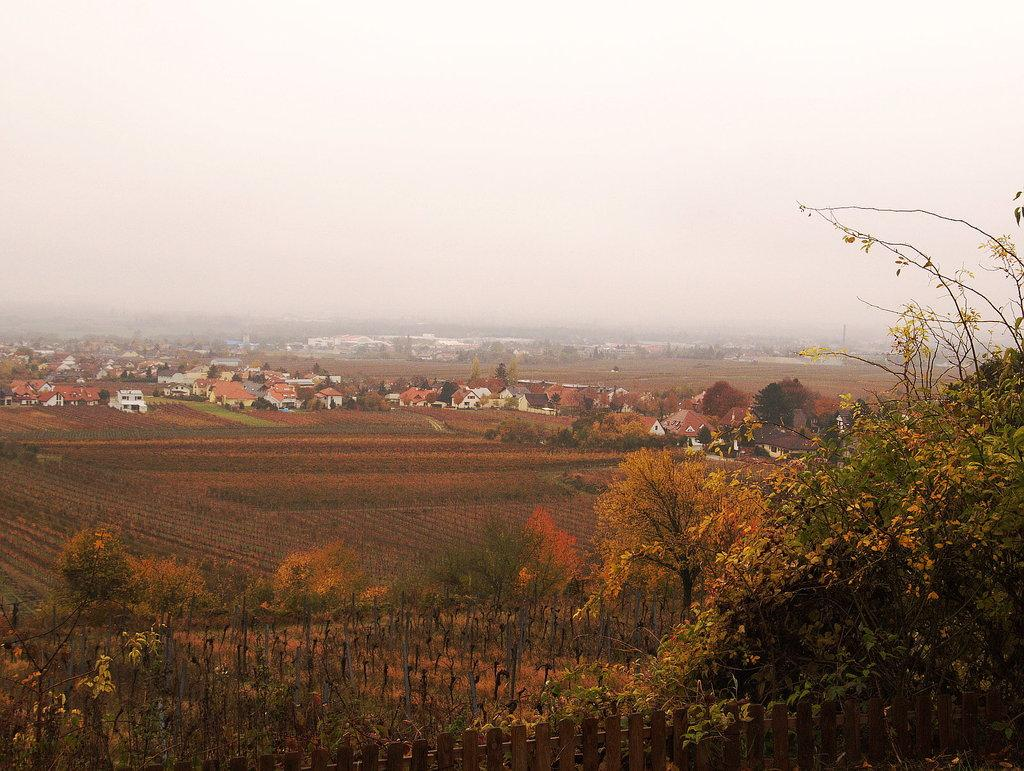What type of natural vegetation can be seen in the image? There are trees in the image. What type of structures are located in the middle of the image? There are houses in the middle of the image. How would you describe the weather condition in the image? The sky is foggy in the image. Can you see a hand holding a riddle in the image? There is no hand or riddle present in the image. Is there a tank visible in the image? There is no tank present in the image. 